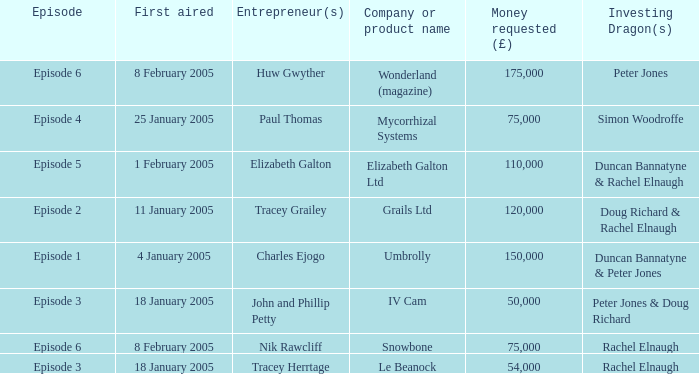Who were the Investing Dragons in the episode that first aired on 18 January 2005 with the entrepreneur Tracey Herrtage? Rachel Elnaugh. 